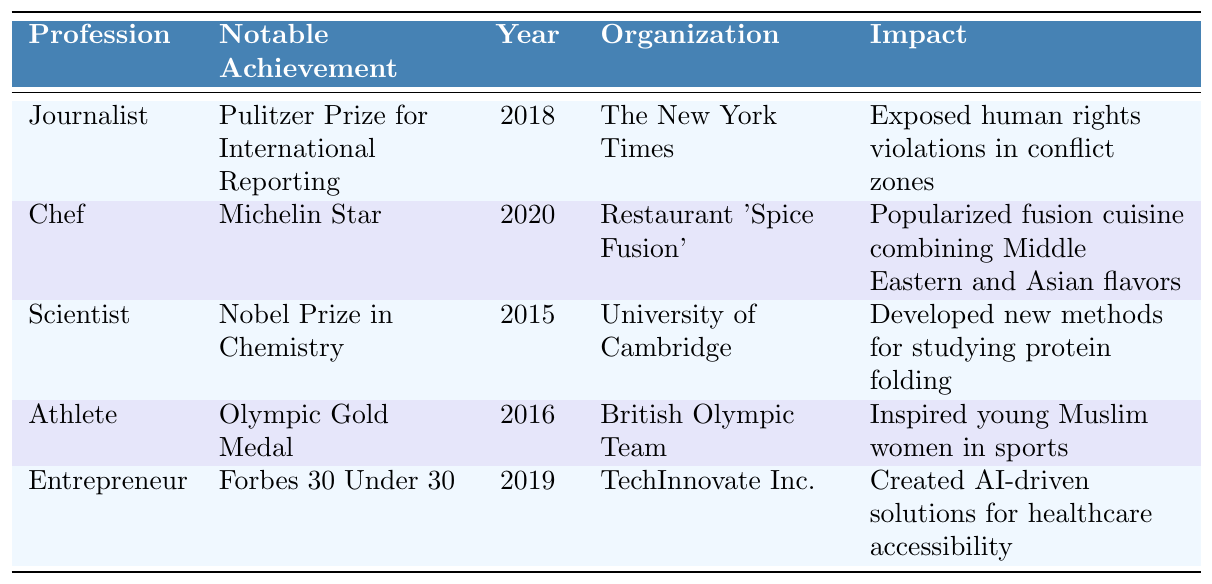What profession did Yasmin Ali achieve a Pulitzer Prize in? The table indicates that Yasmin Ali received a Pulitzer Prize for International Reporting as a Journalist.
Answer: Journalist Which year did Yasmin Ali win the Nobel Prize in Chemistry? According to the table, Yasmin Ali was awarded the Nobel Prize in Chemistry in 2015.
Answer: 2015 Is there an entry for Yasmin Ali who is an Athlete? Yes, the table shows that Yasmin Ali is listed as an Athlete and won an Olympic Gold Medal.
Answer: Yes What notable achievement did Yasmin Ali achieve in 2020? The table states that in 2020, Yasmin Ali, as a Chef, received a Michelin Star.
Answer: Michelin Star Which organization recognized Yasmin Ali as part of the Forbes 30 Under 30? The table shows that Yasmin Ali was recognized by TechInnovate Inc. as part of the Forbes 30 Under 30 in 2019.
Answer: TechInnovate Inc How many achievements are listed for Yasmin Ali in the table? The table contains a total of 5 entries, each representing a different achievement by Yasmin Ali in various professions.
Answer: 5 Which profession had the earliest achievement listed in the table? The table lists a Nobel Prize in Chemistry in 2015 as the earliest achievement, which corresponds to the profession of Scientist.
Answer: Scientist What impact did Yasmin Ali's achievement as an Athlete have? The table states that her Olympic Gold Medal inspired young Muslim women in sports.
Answer: Inspired young Muslim women in sports In how many different professions is Yasmin Ali recognized in the table? The table shows that Yasmin Ali is recognized in 5 different professions: Journalist, Chef, Scientist, Athlete, and Entrepreneur.
Answer: 5 What is the difference in years between Yasmin Ali's Michelin Star and her Olympic Gold Medal? The Michelin Star was awarded in 2020 and the Olympic Gold Medal in 2016. The difference is: 2020 - 2016 = 4 years.
Answer: 4 years 